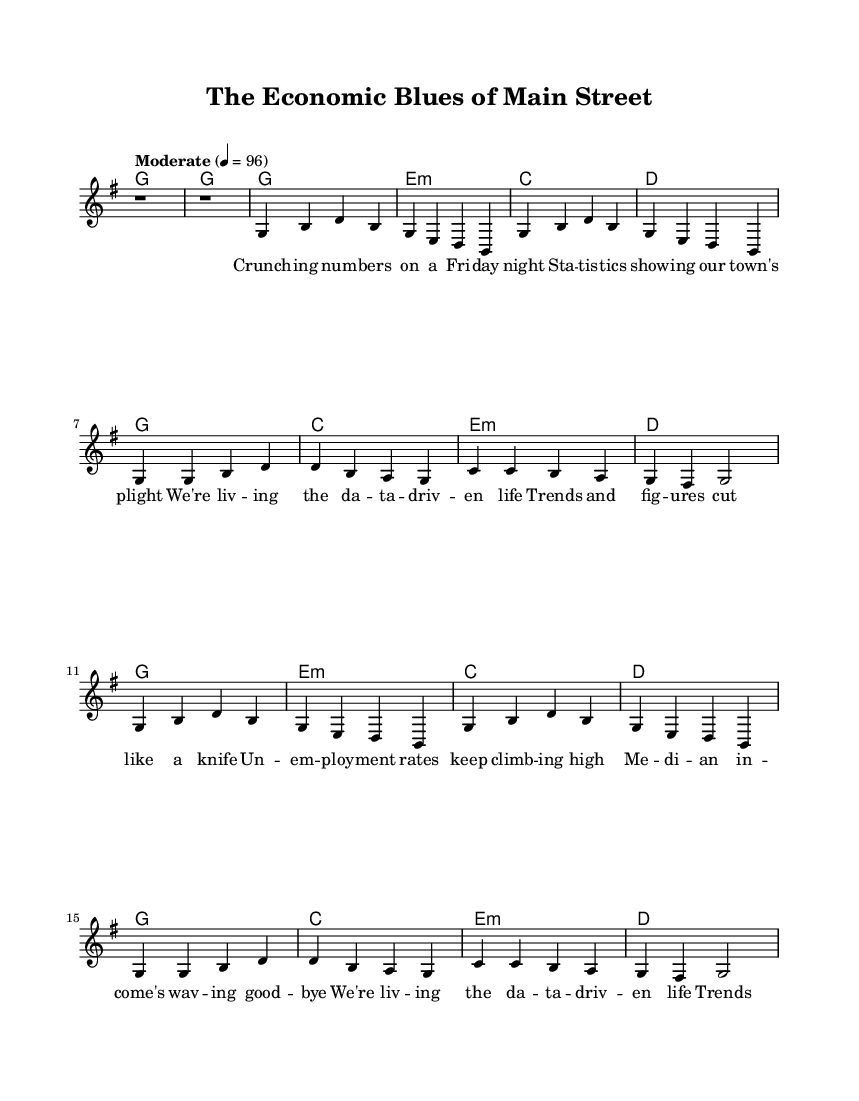What is the key signature of this music? The key signature is G major, which has one sharp (F#). This can be determined from the initial indication at the beginning of the score where it states \key g \major.
Answer: G major What is the time signature of this music? The time signature is 4/4, as indicated at the beginning of the score. This means there are four beats in each measure, and a quarter note receives one beat.
Answer: 4/4 What is the tempo marking for this piece? The tempo marking is "Moderate" with a beat of 96. It can be found right at the start of the score, indicating the speed at which the piece should be played.
Answer: Moderate 4 = 96 How many verses are in this song? There are two verses in the song, as indicated by the structure of the lyrics provided under the melody, where the first and second sections are labeled as Verse 1 and Verse 2 respectively.
Answer: 2 What is the primary theme of the lyrics? The primary theme focuses on economic challenges, as evidenced by the references to statistics, unemployment rates, and median income, which are prevalent throughout the verses.
Answer: Economic challenges What type of harmonic structure does this song use? The song uses a common chord progression typical in Country music consisting of the chords G, E minor, C, and D, which can be analyzed from the harmonic section of the score.
Answer: Common chord progression What is the emotional tone expressed in the lyrics? The emotional tone is one of struggle and concern in response to economic difficulties faced by rural America, as reflected in phrases about unemployment and income decline.
Answer: Struggle and concern 